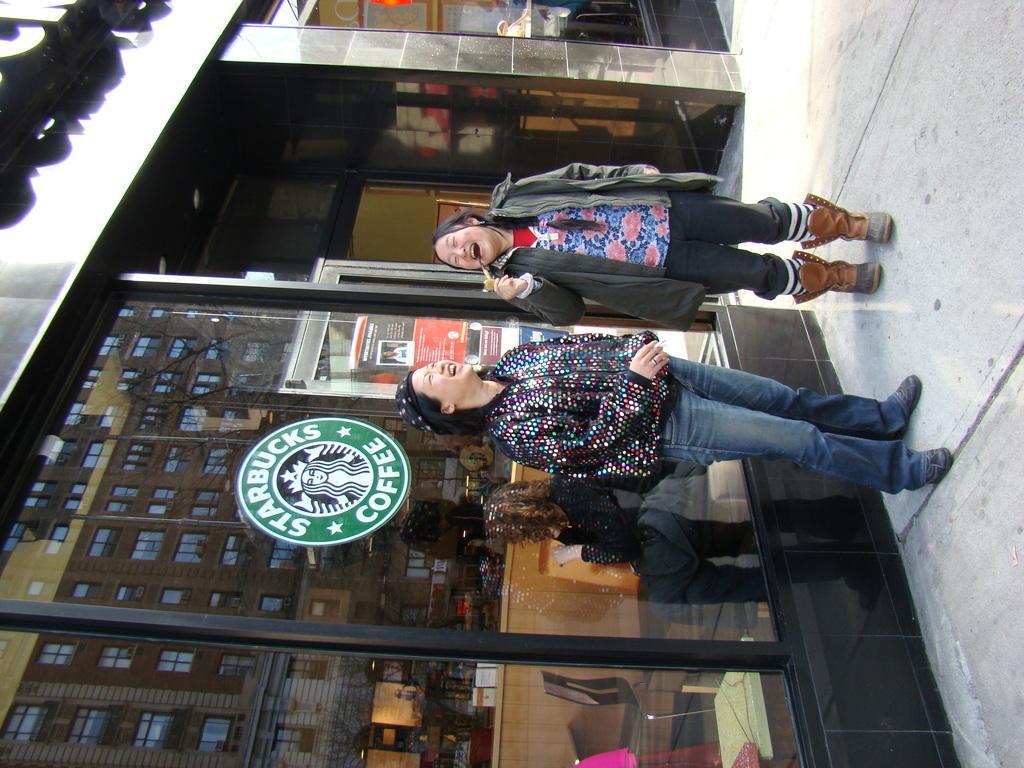In one or two sentences, can you explain what this image depicts? In this image there are two women standing on the floor and laughing in front of the coffee shop. On the left side top there is a hoarding. Behind the woman there is a glass on which there is a symbol. In the coffee shop there are chairs and tables. 